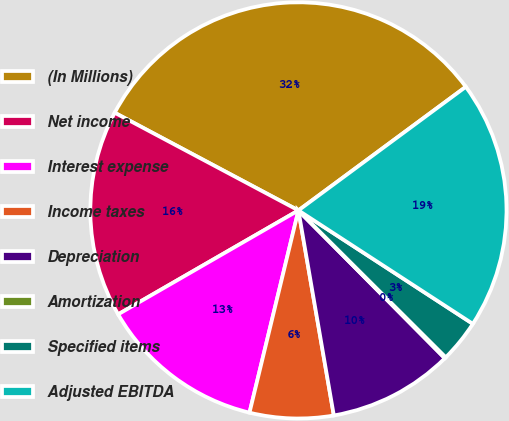Convert chart. <chart><loc_0><loc_0><loc_500><loc_500><pie_chart><fcel>(In Millions)<fcel>Net income<fcel>Interest expense<fcel>Income taxes<fcel>Depreciation<fcel>Amortization<fcel>Specified items<fcel>Adjusted EBITDA<nl><fcel>32.1%<fcel>16.1%<fcel>12.9%<fcel>6.5%<fcel>9.7%<fcel>0.1%<fcel>3.3%<fcel>19.3%<nl></chart> 